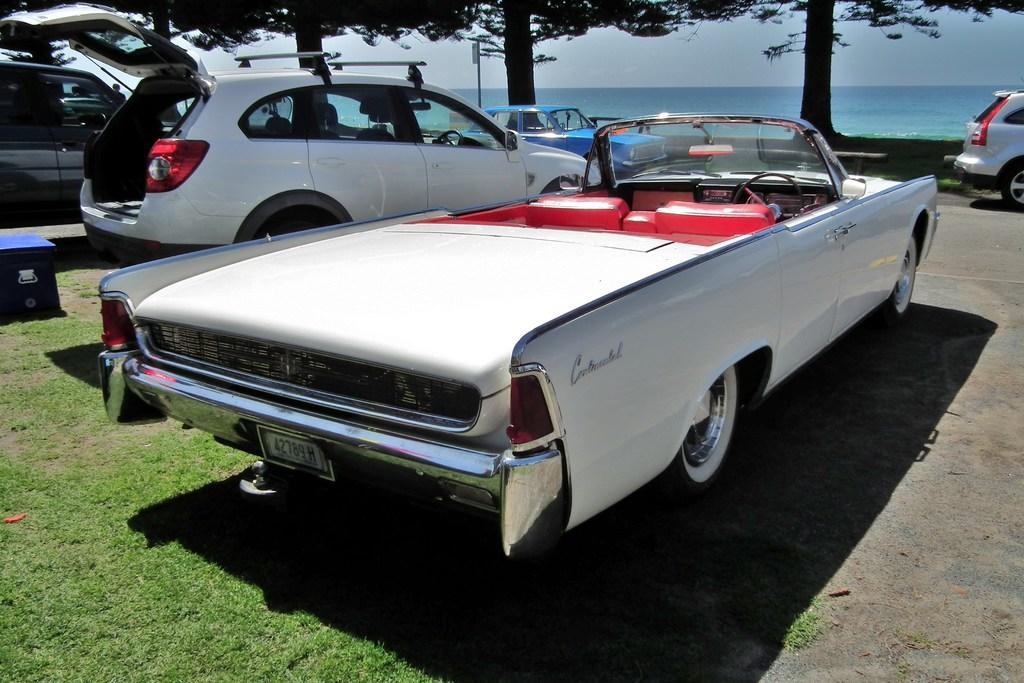What types of vehicles are present in the image? There are different cars in the image. What can be seen behind the cars? There are trees behind the cars. What is visible beyond the trees? There is a water surface visible behind the trees. What type of cream is being used to paint the cars in the image? There is no indication in the image that the cars are being painted, and therefore no mention of cream can be made. 